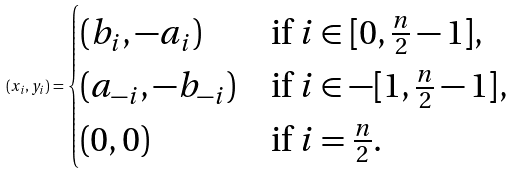Convert formula to latex. <formula><loc_0><loc_0><loc_500><loc_500>( x _ { i } , y _ { i } ) = \begin{cases} ( b _ { i } , - a _ { i } ) & \text {if $i\in[0,\frac{n}{2}-1]$} , \\ ( a _ { - i } , - b _ { - i } ) & \text {if $i\in-[1,\frac{n}{2}-1]$} , \\ ( 0 , 0 ) & \text {if $i=\frac{n}{2}$} . \end{cases}</formula> 